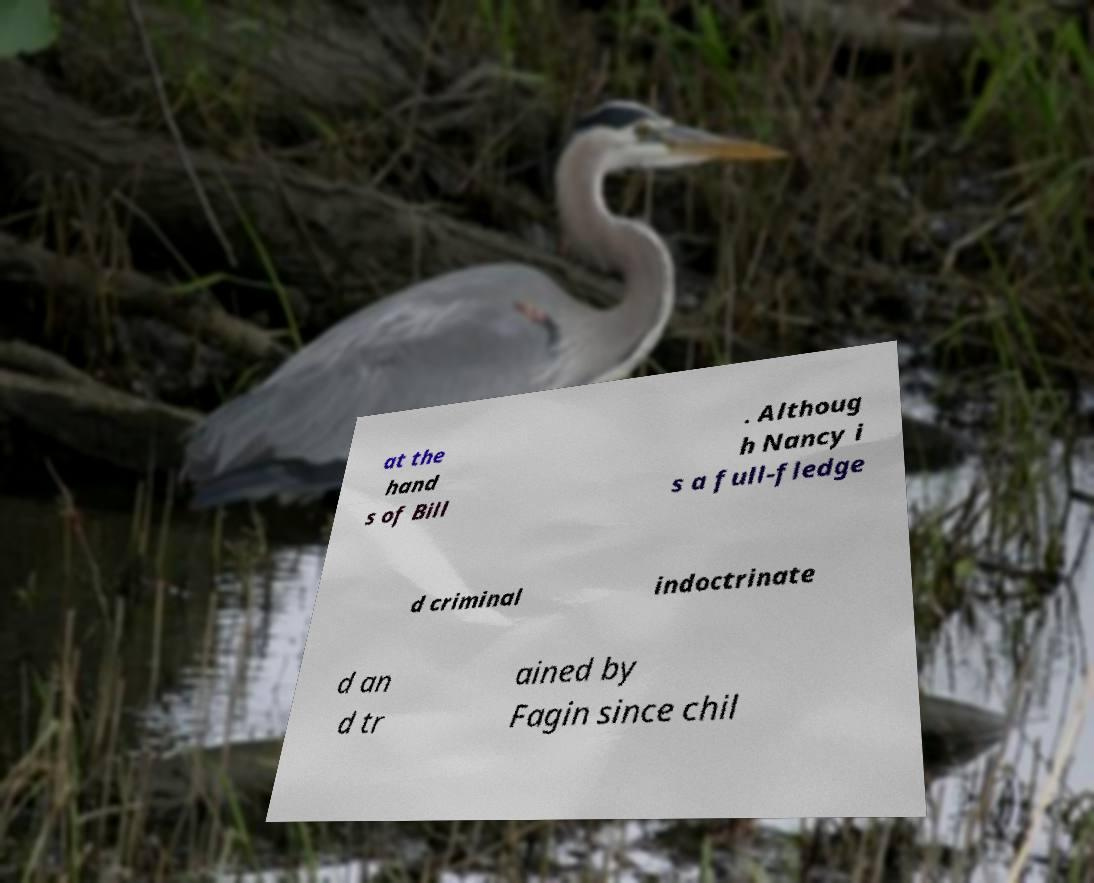Please read and relay the text visible in this image. What does it say? at the hand s of Bill . Althoug h Nancy i s a full-fledge d criminal indoctrinate d an d tr ained by Fagin since chil 